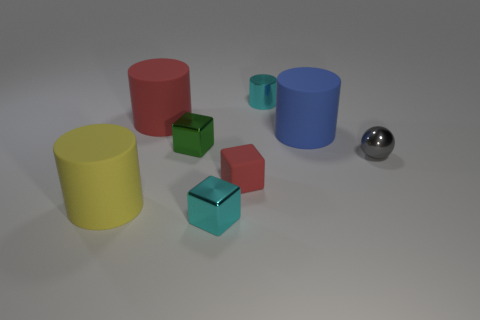Add 2 small rubber cubes. How many objects exist? 10 Subtract all cyan shiny blocks. How many blocks are left? 2 Add 4 spheres. How many spheres are left? 5 Add 7 rubber cubes. How many rubber cubes exist? 8 Subtract all yellow cylinders. How many cylinders are left? 3 Subtract 0 red balls. How many objects are left? 8 Subtract all balls. How many objects are left? 7 Subtract 2 cubes. How many cubes are left? 1 Subtract all blue blocks. Subtract all red cylinders. How many blocks are left? 3 Subtract all red cylinders. How many green blocks are left? 1 